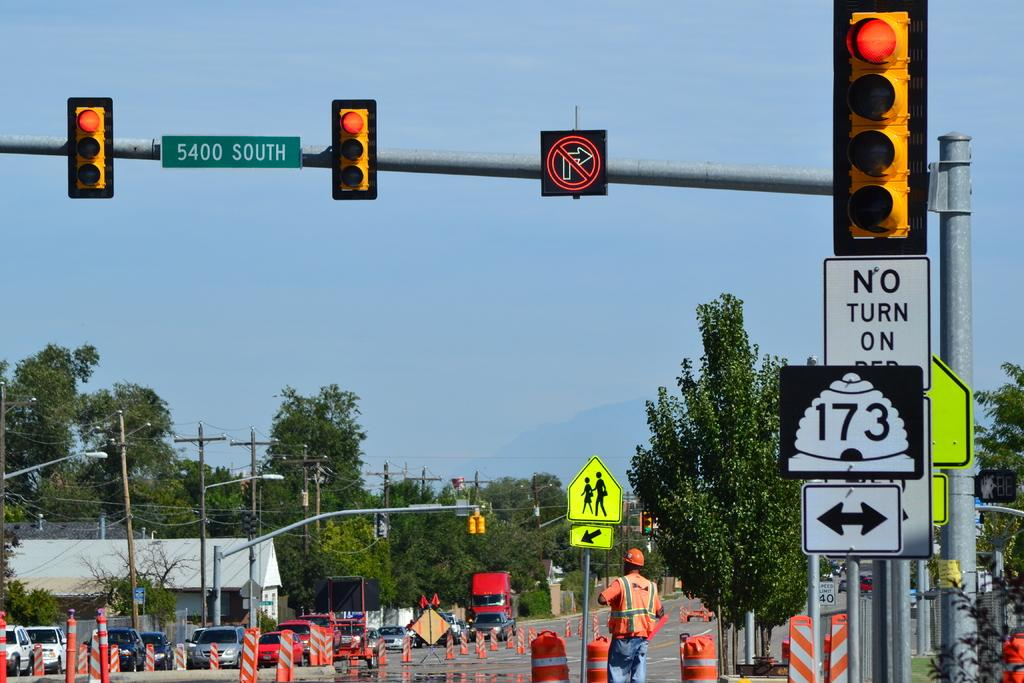Provide a one-sentence caption for the provided image. The traffic lights at the 5400 South intersection are red. 